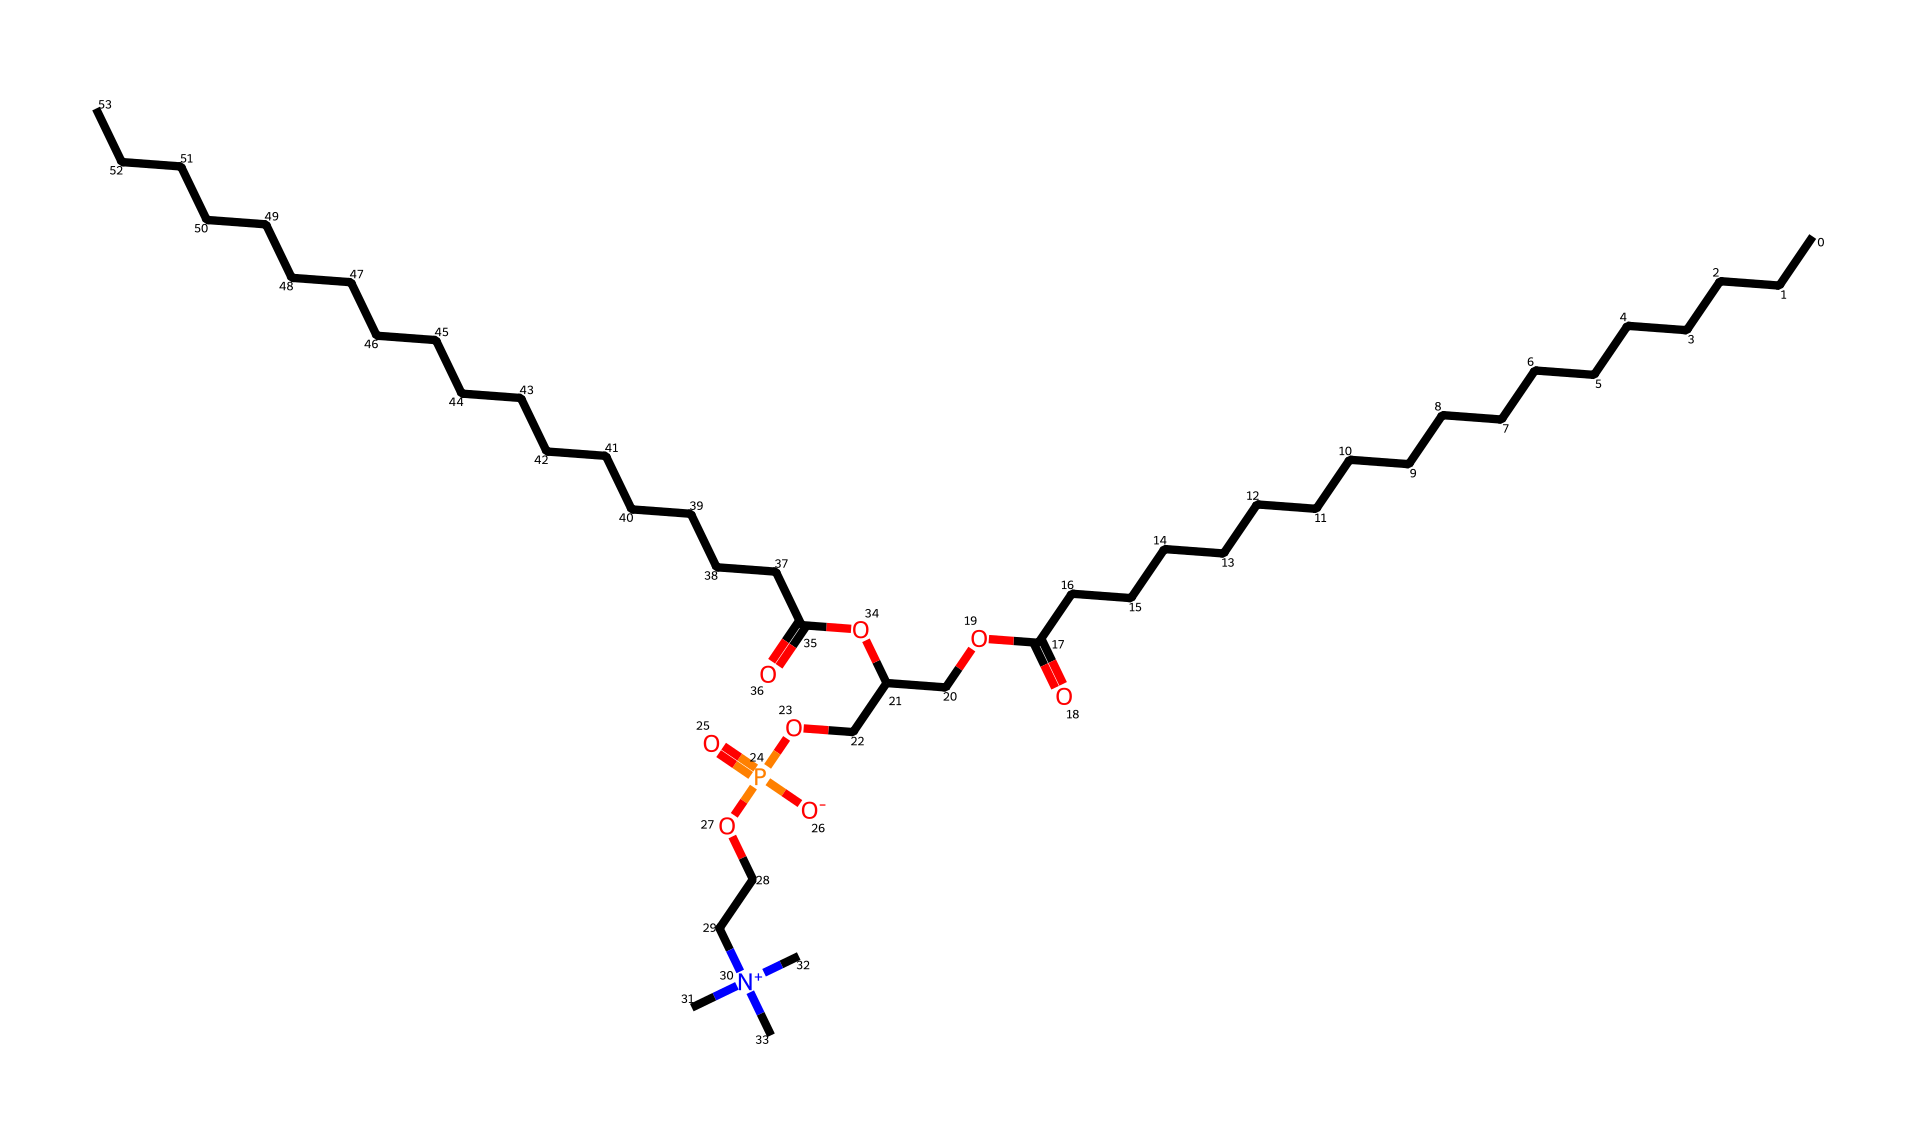What is the molecular formula of this chemical? The chemical's SMILES representation includes carbon (C), hydrogen (H), oxygen (O), and phosphorus (P). Counting the atoms for each element within the structure gives the molecular formula C34H65N1O8P1.
Answer: C34H65N1O8P1 How many oxygen atoms are present in the structure? By decoding the SMILES string, we can see that there are eight 'O' symbols in the representation, which indicates the presence of eight oxygen atoms.
Answer: 8 What type of surfactant is lecithin classified as? Lecithin is classified as a phospholipid surfactant, which are known to reduce surface tension and form micelles due to their amphiphilic nature.
Answer: phospholipid What functional groups are prominent in this chemical? Analyzing the chemical structure reveals the presence of carboxylic acid, ester, and phosphate functional groups, which play crucial roles in its properties and functions.
Answer: carboxylic acid, ester, phosphate How does lecithin promote women's health? Lecithin contains choline, which is essential for brain health and metabolism, helping address issues such as cognitive decline and hormonal balance, particularly important for women.
Answer: choline Which part of lecithin is amphiphilic? The structure contains both hydrophilic (the phosphate group) and hydrophobic (the long hydrocarbon chains) components, making it amphiphilic, essential for surfactant activity.
Answer: phosphate group and hydrocarbon chains 